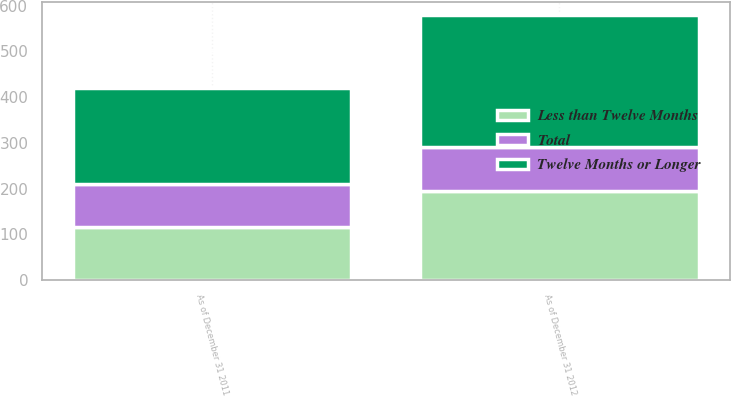<chart> <loc_0><loc_0><loc_500><loc_500><stacked_bar_chart><ecel><fcel>As of December 31 2012<fcel>As of December 31 2011<nl><fcel>Less than Twelve Months<fcel>195<fcel>117<nl><fcel>Total<fcel>95<fcel>93<nl><fcel>Twelve Months or Longer<fcel>290<fcel>210<nl></chart> 